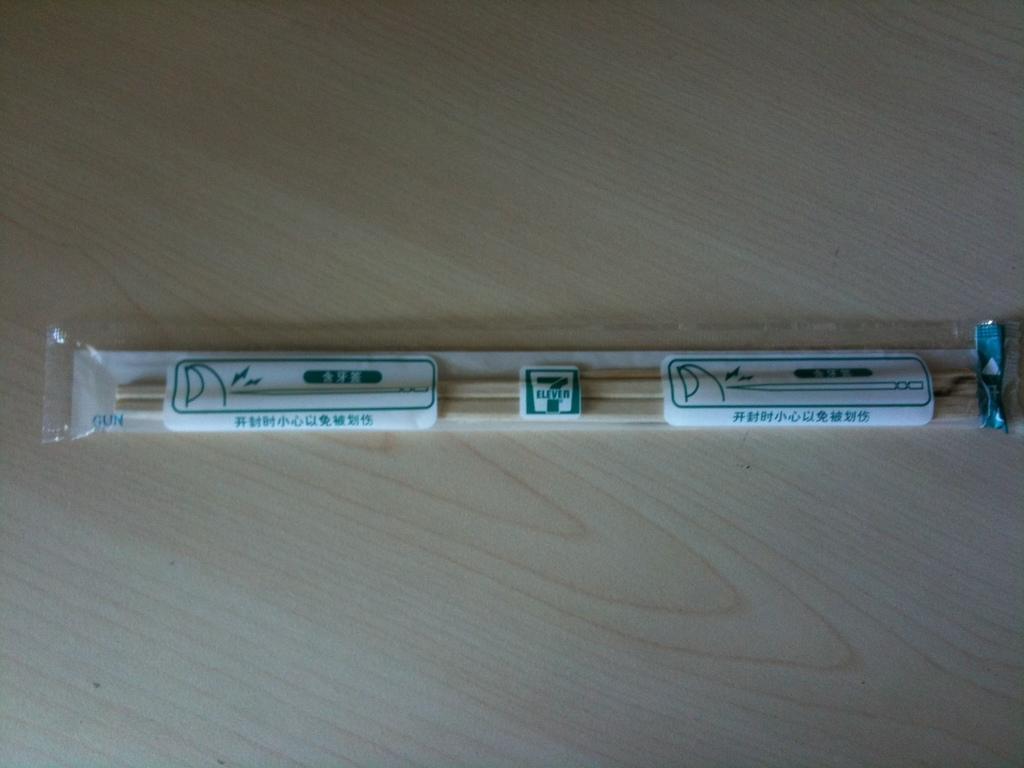Describe this image in one or two sentences. In the image we can see there is a plastic cover in which there are wooden chopstick. 